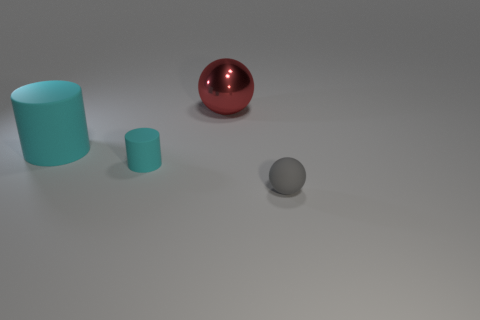Based on the lighting and shadows, where do you think the light source is located? Observing the shadows and highlights, the light source appears to be coming from the upper left side of the image, as indicated by the shadows cast to the lower right of the objects. 